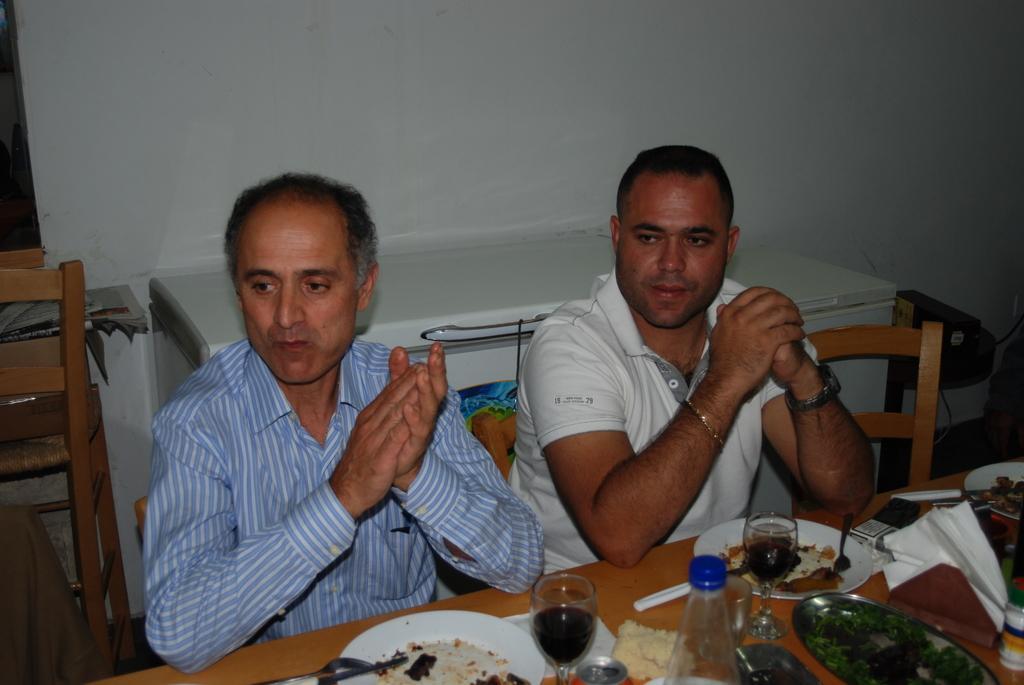Could you give a brief overview of what you see in this image? In this image we can see two persons sitting on the chair and we can also see some food items placed on the wooden table. 